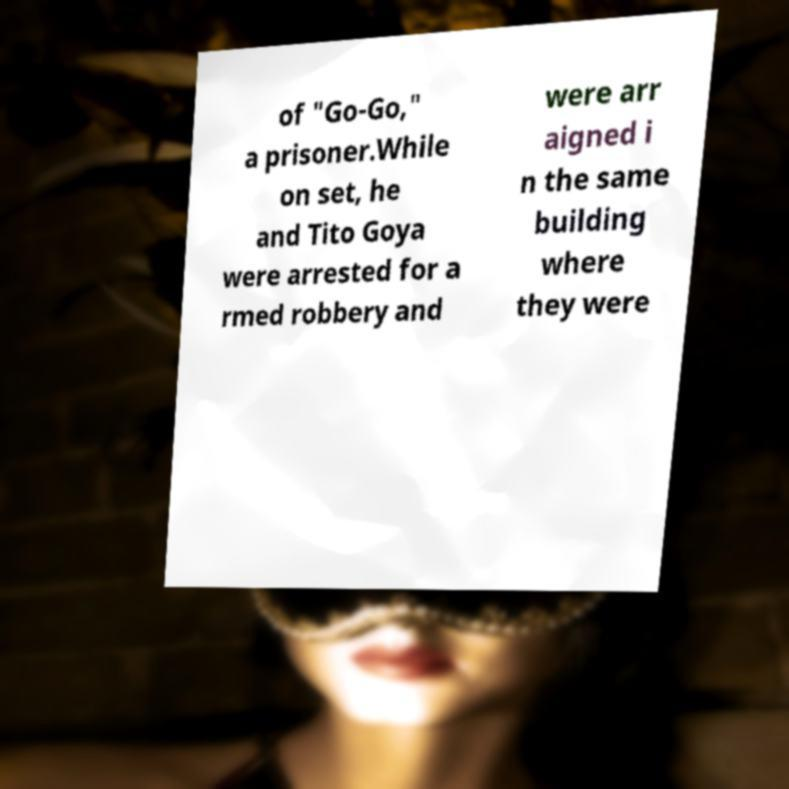Please read and relay the text visible in this image. What does it say? of "Go-Go," a prisoner.While on set, he and Tito Goya were arrested for a rmed robbery and were arr aigned i n the same building where they were 